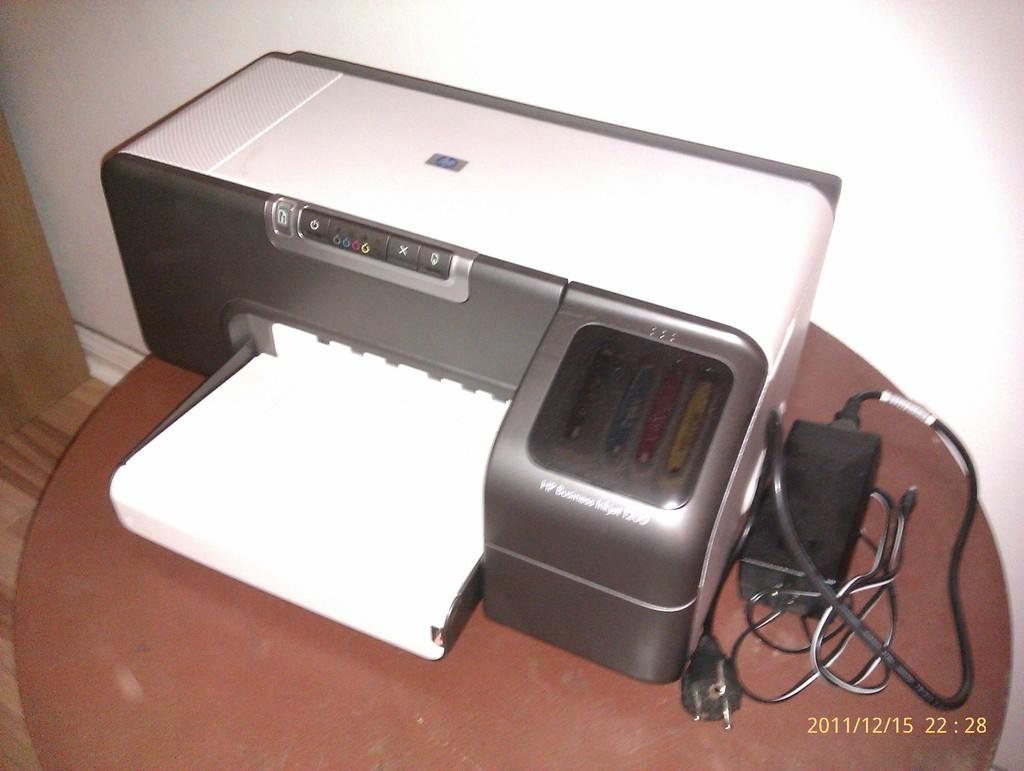What device can be seen in the image? There is a printer in the image. What is connected to the printer in the image? There is a wire on the table in the image. What can be seen in the background of the image? There is a wall visible in the image. What is visible below the table in the image? There is ground visible in the image. What is located on the left side of the image? There is an object on the left side of the image. How many legs does the snake have in the image? There is no snake present in the image. What type of toad can be seen hopping on the ground in the image? There is no toad present in the image. 